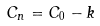Convert formula to latex. <formula><loc_0><loc_0><loc_500><loc_500>C _ { n } = C _ { 0 } - k</formula> 